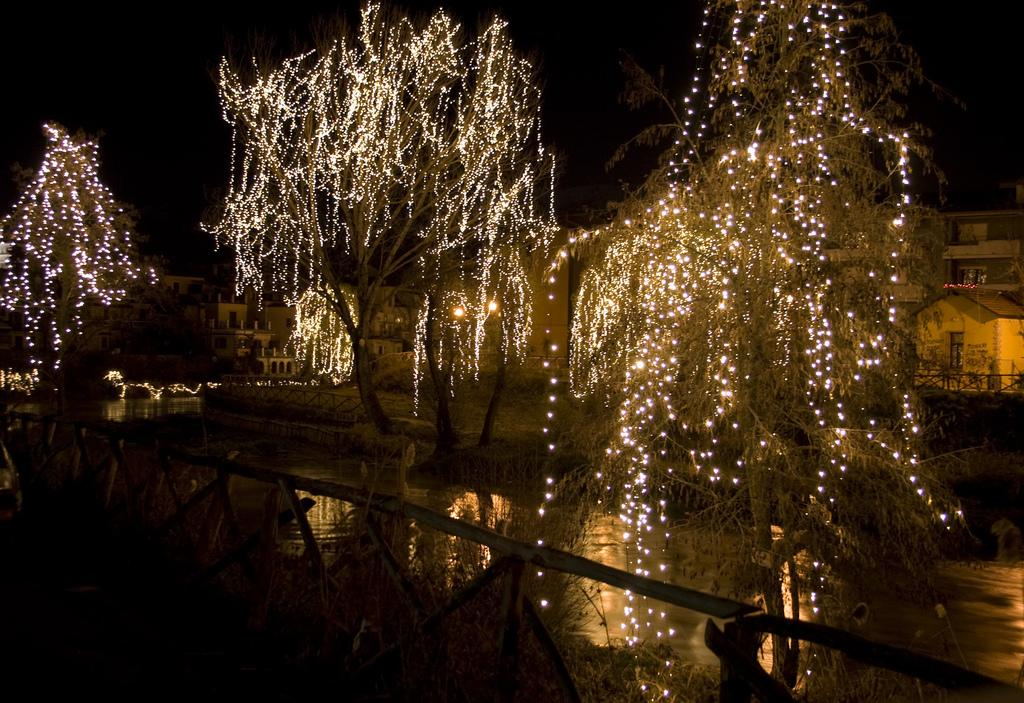What is visible in the image? Water is visible in the image. What can be seen in the background of the image? There are trees and buildings in the background of the image. How are the trees decorated? The trees are decorated with lights. What is the color of the sky in the image? The sky is black in color. What is your opinion on the waste management practices in the image? There is no information about waste management practices in the image, so it's not possible to provide an opinion on that topic. 